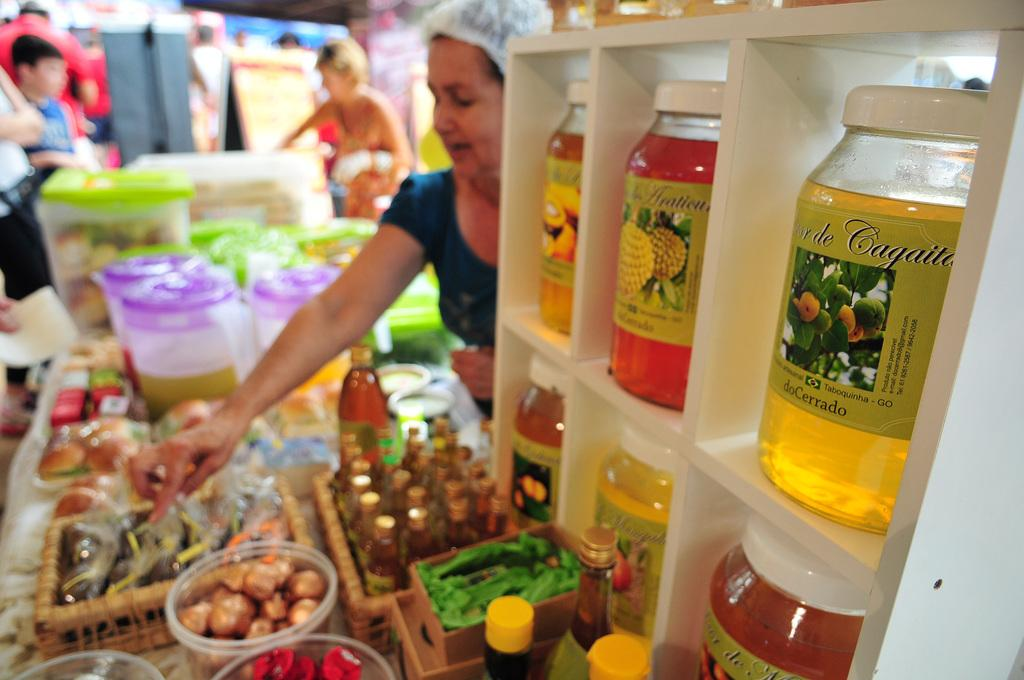What types of containers are visible in the image? There are jars, bottles, baskets, and boxes in the image. What is inside the containers? There are food items in the image. Are there any other objects visible in the image? Yes, there are some objects in the image. Can you describe the people in the background of the image? There are people in the background of the image, but their specific features cannot be discerned due to the blurry background. What else can be seen in the background of the image? There are posters in the background of the image. What is the desire of the doll in the image? There is no doll present in the image, so it is not possible to determine the desire of a doll. 